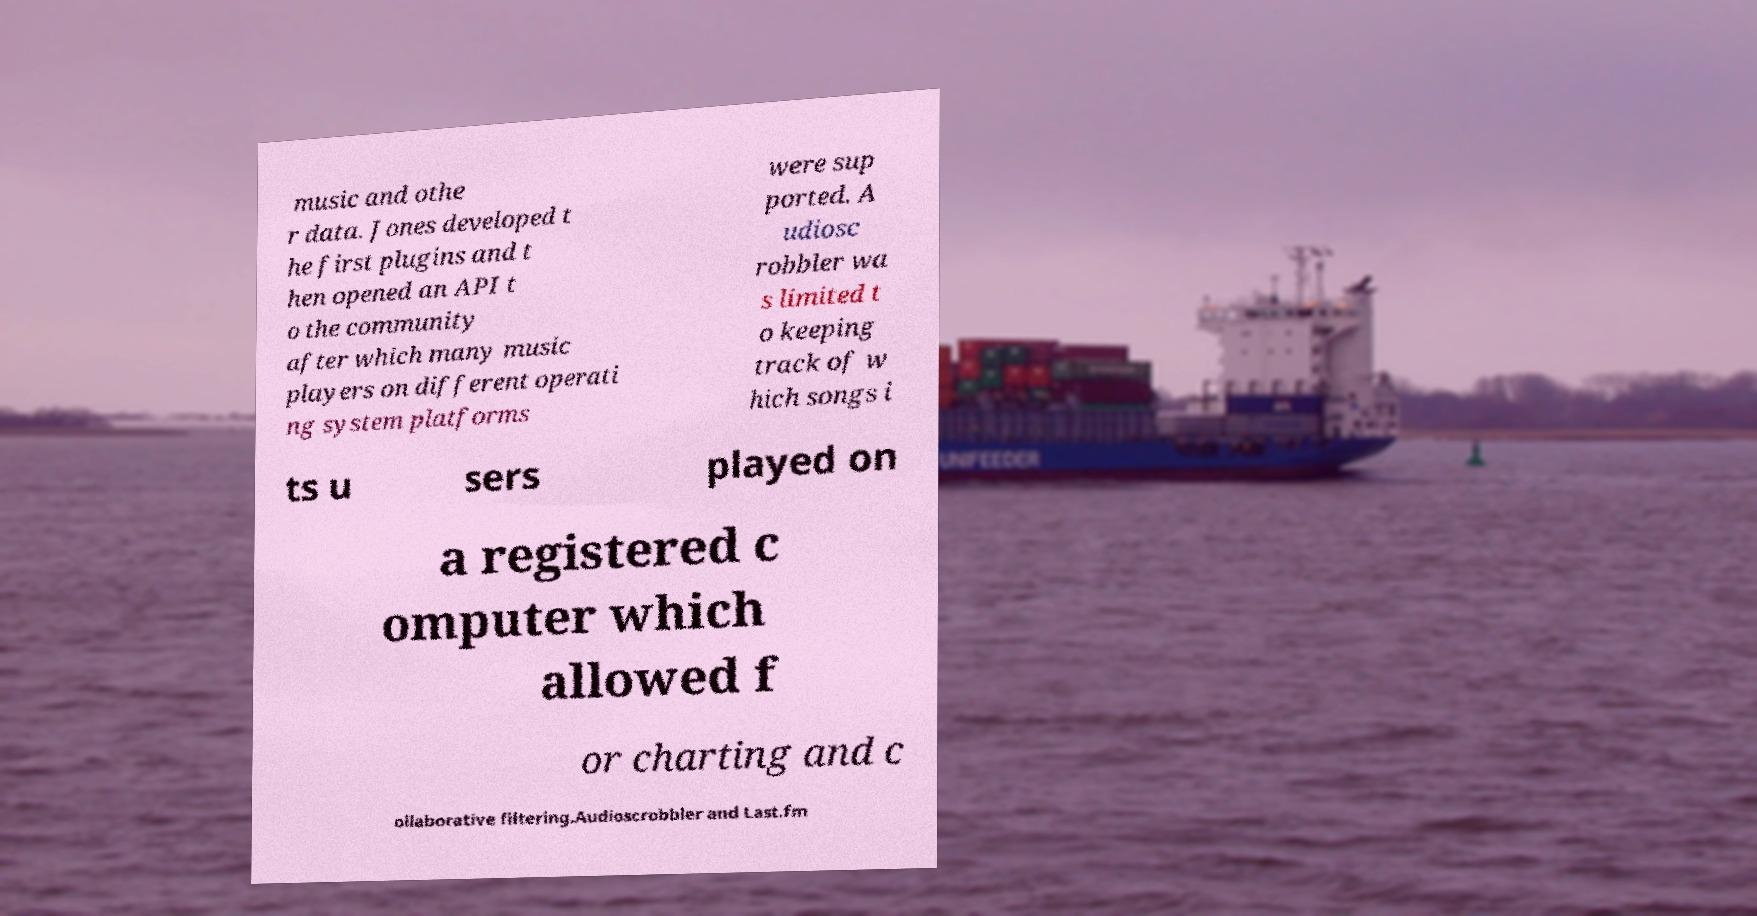Could you extract and type out the text from this image? music and othe r data. Jones developed t he first plugins and t hen opened an API t o the community after which many music players on different operati ng system platforms were sup ported. A udiosc robbler wa s limited t o keeping track of w hich songs i ts u sers played on a registered c omputer which allowed f or charting and c ollaborative filtering.Audioscrobbler and Last.fm 